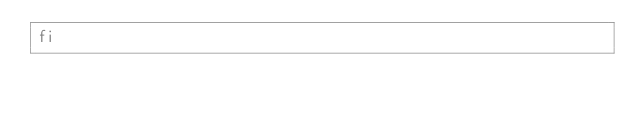<code> <loc_0><loc_0><loc_500><loc_500><_Bash_>fi</code> 